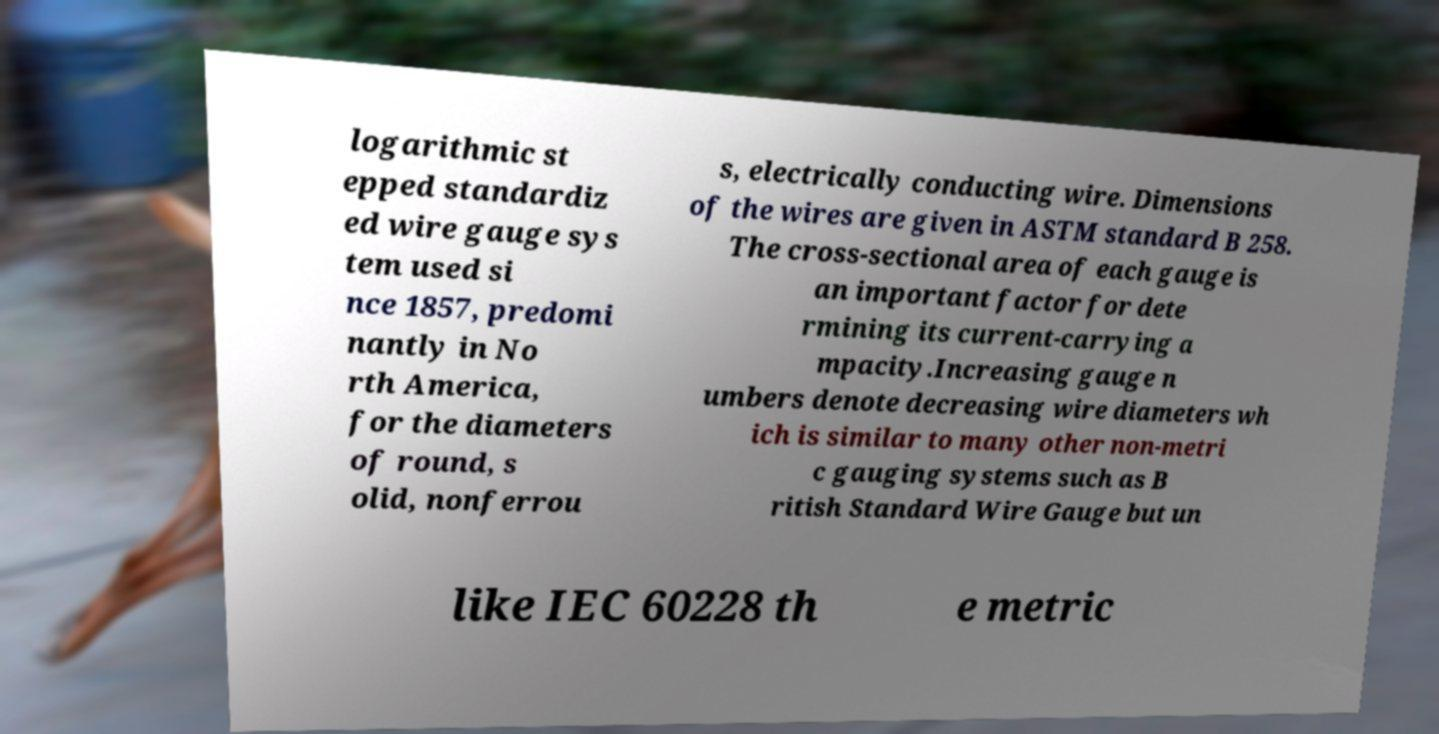For documentation purposes, I need the text within this image transcribed. Could you provide that? logarithmic st epped standardiz ed wire gauge sys tem used si nce 1857, predomi nantly in No rth America, for the diameters of round, s olid, nonferrou s, electrically conducting wire. Dimensions of the wires are given in ASTM standard B 258. The cross-sectional area of each gauge is an important factor for dete rmining its current-carrying a mpacity.Increasing gauge n umbers denote decreasing wire diameters wh ich is similar to many other non-metri c gauging systems such as B ritish Standard Wire Gauge but un like IEC 60228 th e metric 